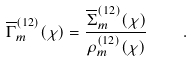Convert formula to latex. <formula><loc_0><loc_0><loc_500><loc_500>\overline { \Gamma } _ { m } ^ { ( 1 2 ) } ( \chi ) = \frac { \overline { \Sigma } ^ { ( 1 2 ) } _ { m } ( \chi ) } { \rho _ { m } ^ { ( 1 2 ) } ( \chi ) } \quad .</formula> 